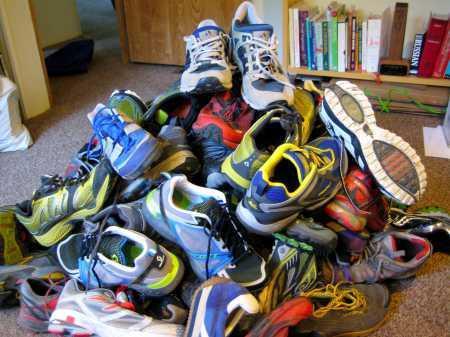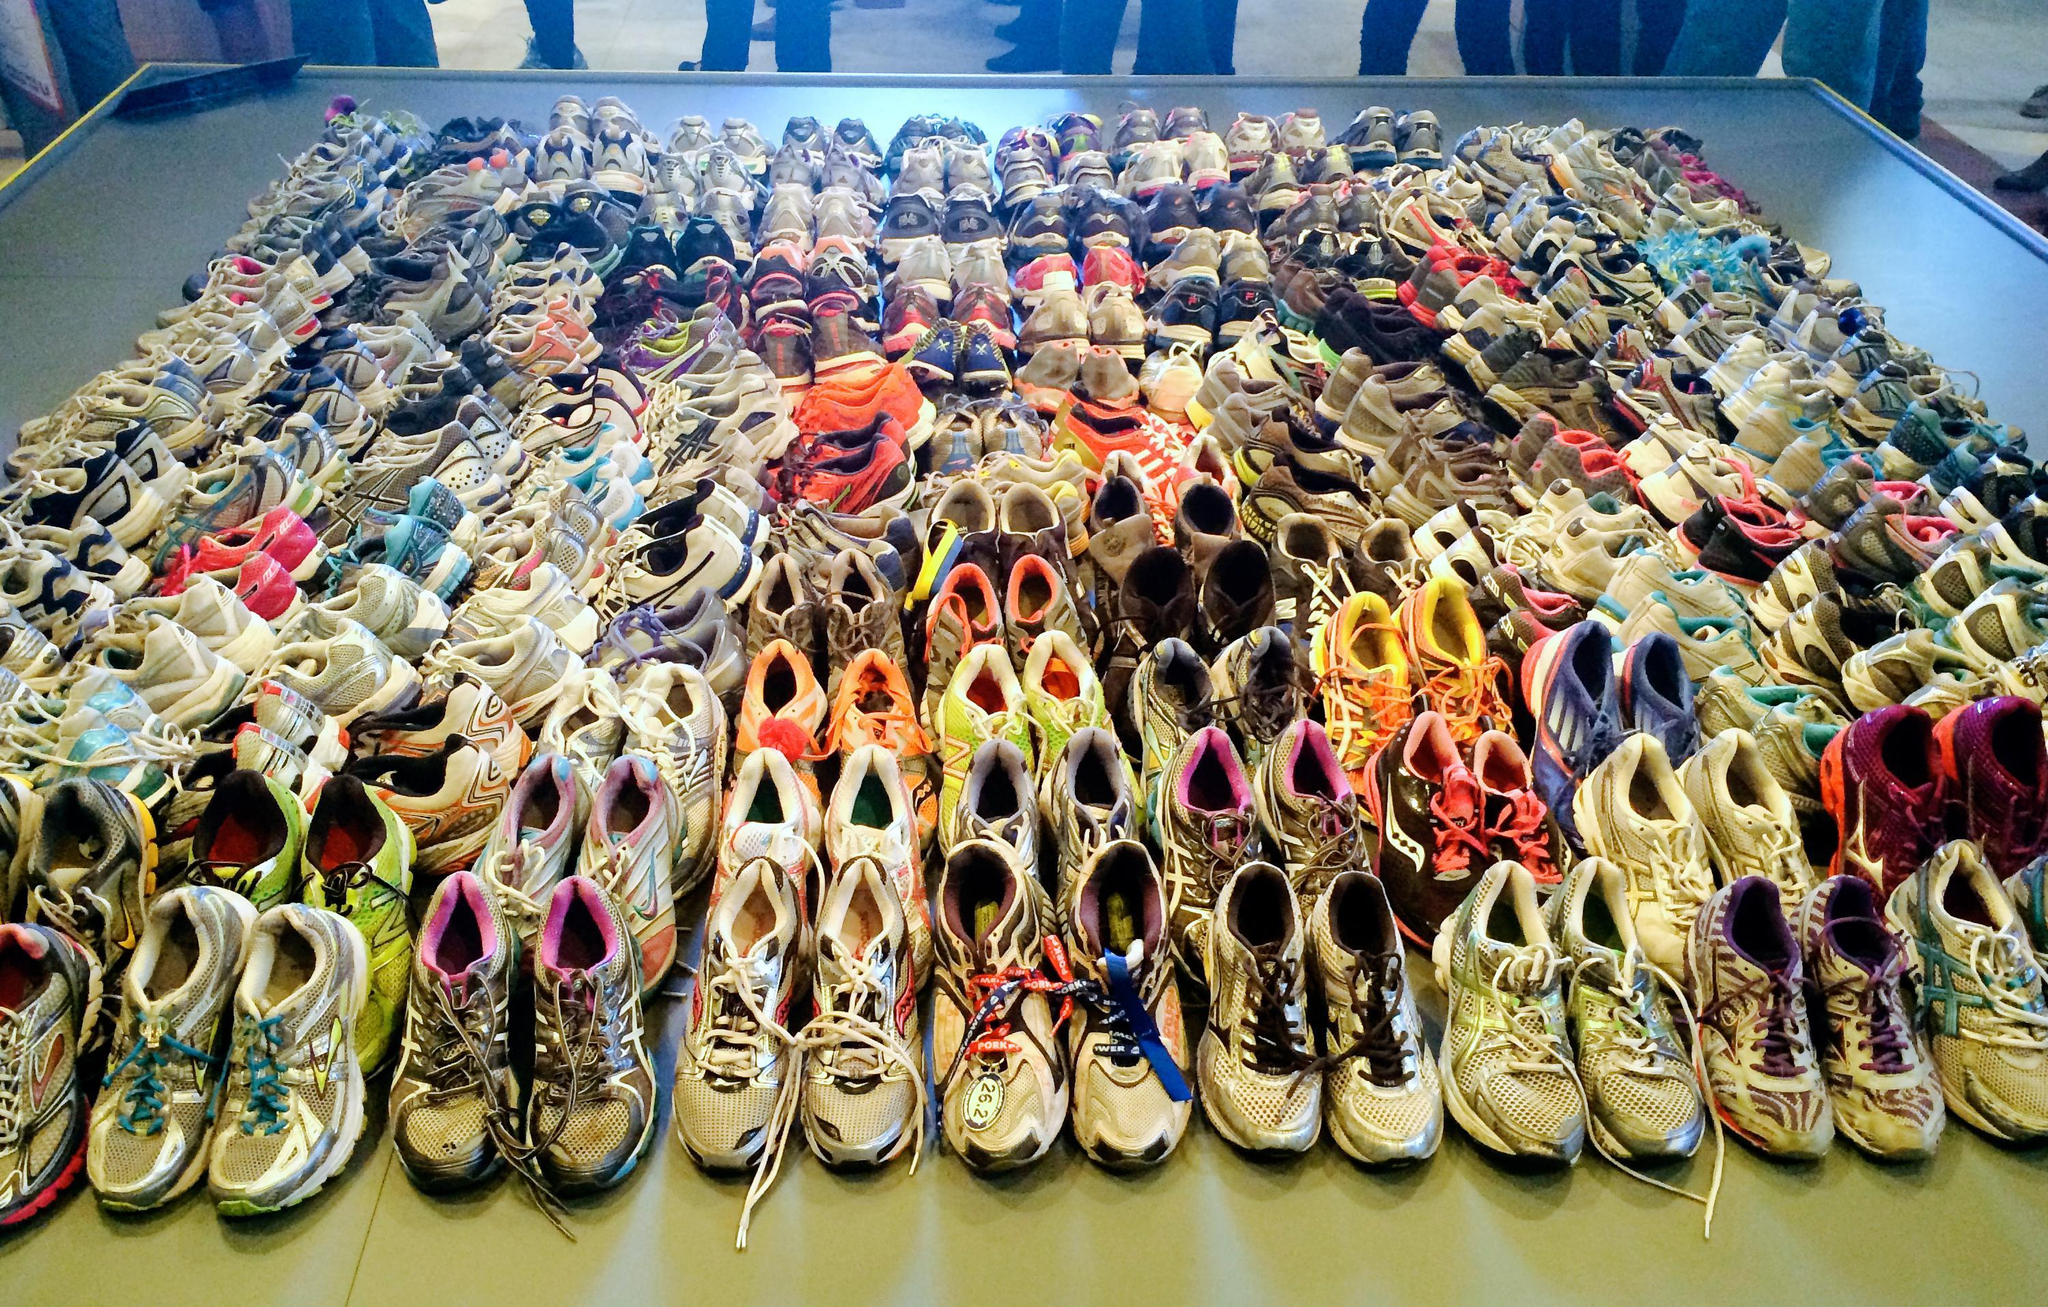The first image is the image on the left, the second image is the image on the right. Examine the images to the left and right. Is the description "At least 30 shoes are piled up and none are in neat rows." accurate? Answer yes or no. No. The first image is the image on the left, the second image is the image on the right. Assess this claim about the two images: "There are piles of athletic shoes sitting on the floor in the center of the images.". Correct or not? Answer yes or no. No. 